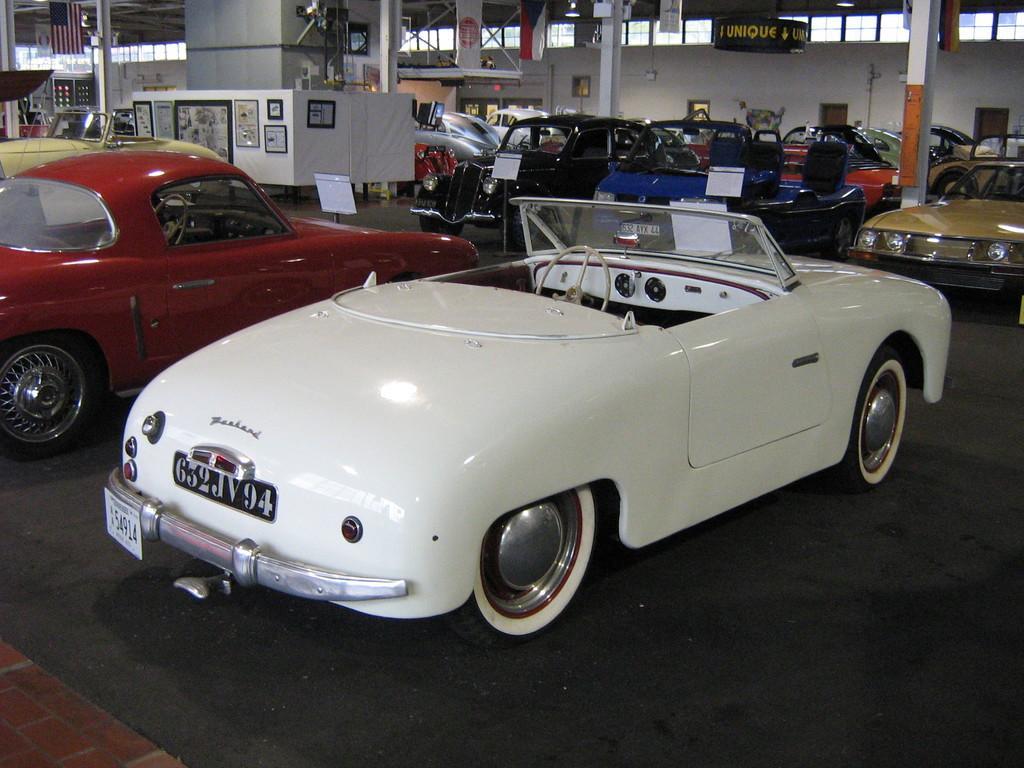In one or two sentences, can you explain what this image depicts? There are vehicles in different colors on the floor of a hall. In the background, there are pillars, there is a generator having meters, there are glass windows and there is white wall. 